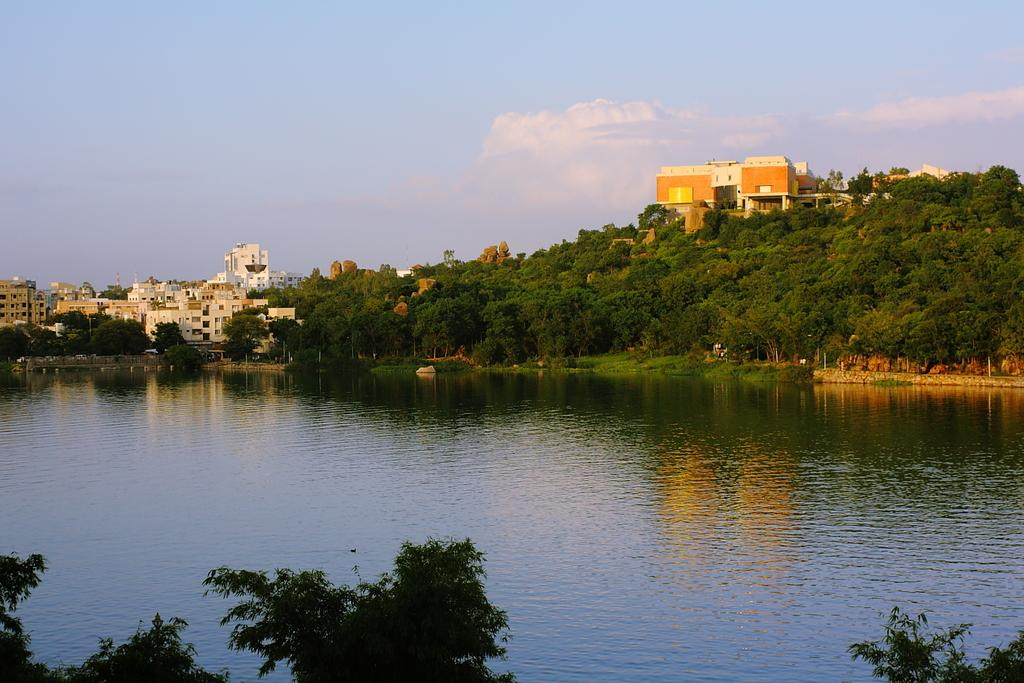What is visible in the image? Water is visible in the image. What can be seen in the background of the image? There are trees, buildings, and the sky visible in the background of the image. What is the condition of the sky in the image? Clouds are present in the sky. What type of organization can be seen in the image? There is no organization present in the image; it features water, trees, buildings, and the sky. Can you tell me how deep the ocean is in the image? There is no ocean present in the image; it features water, but not an ocean. 